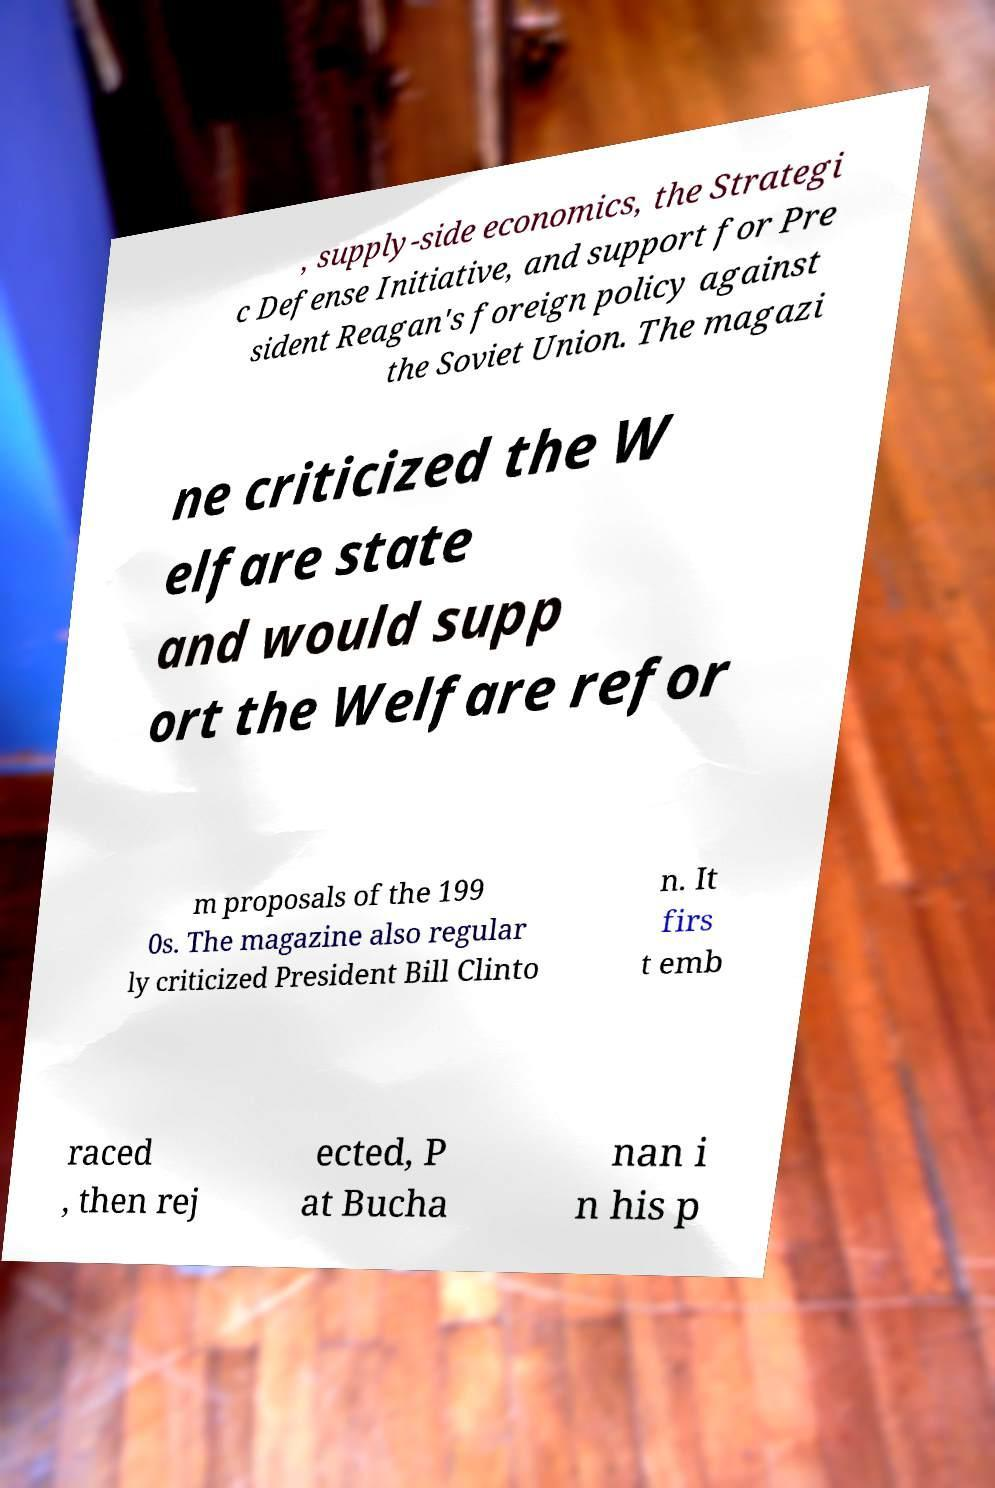Could you assist in decoding the text presented in this image and type it out clearly? , supply-side economics, the Strategi c Defense Initiative, and support for Pre sident Reagan's foreign policy against the Soviet Union. The magazi ne criticized the W elfare state and would supp ort the Welfare refor m proposals of the 199 0s. The magazine also regular ly criticized President Bill Clinto n. It firs t emb raced , then rej ected, P at Bucha nan i n his p 